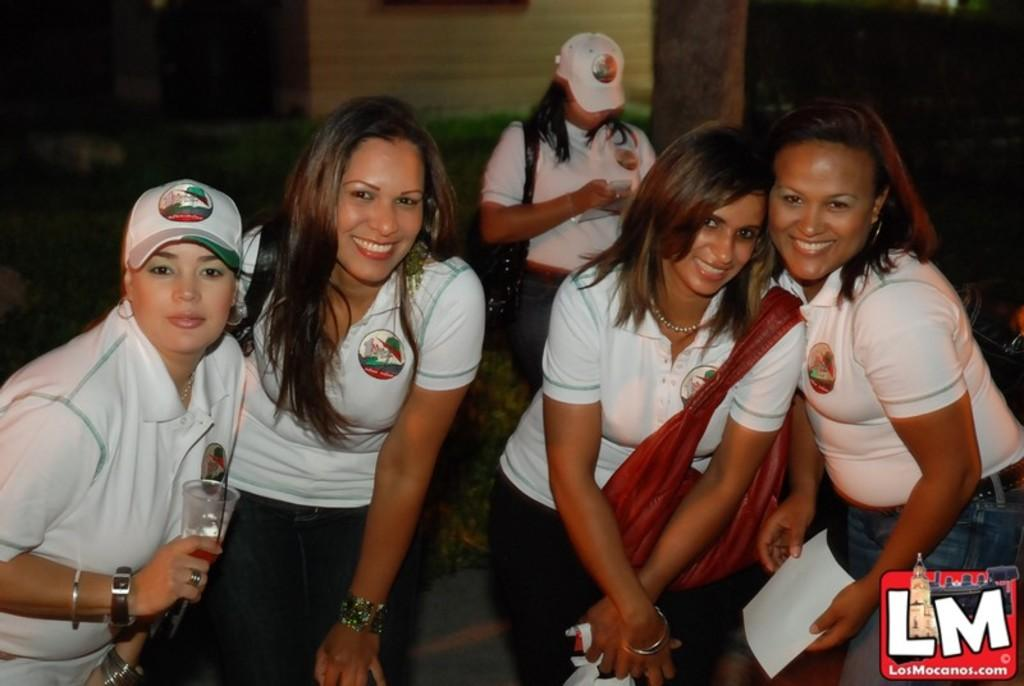Who is present in the image? There are women in the image. What natural element can be seen in the image? There is a tree trunk in the image. What man-made structure is visible in the image? There is a wall in the image. What is the color of the background in the image? The background of the image is dark. Where is the logo located in the image? The logo is in the bottom right side of the image. What type of pear is hanging from the tree trunk in the image? There is no pear present in the image; it features a tree trunk without any fruit. Can you see a giraffe in the image? No, there is no giraffe present in the image. Was there an earthquake that caused the wall to crack in the image? There is no indication of an earthquake or any damage to the wall in the image. 